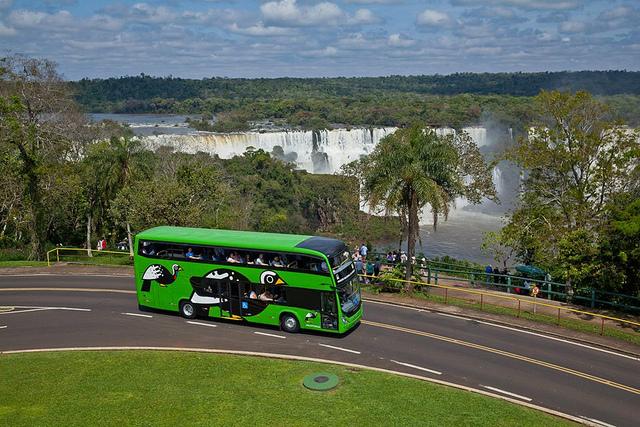Is there a waterfall?
Write a very short answer. Yes. Which way is the bus driving?
Quick response, please. Right. Is it cloudy or clear?
Answer briefly. Cloudy. How many levels of seating are on the bus?
Concise answer only. 2. 